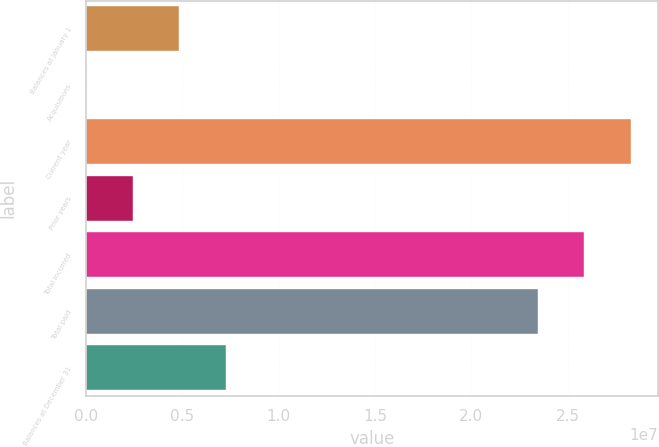<chart> <loc_0><loc_0><loc_500><loc_500><bar_chart><fcel>Balances at January 1<fcel>Acquisitions<fcel>Current year<fcel>Prior years<fcel>Total incurred<fcel>Total paid<fcel>Balances at December 31<nl><fcel>4.83131e+06<fcel>4.72<fcel>2.82831e+07<fcel>2.41566e+06<fcel>2.58674e+07<fcel>2.34518e+07<fcel>7.24696e+06<nl></chart> 